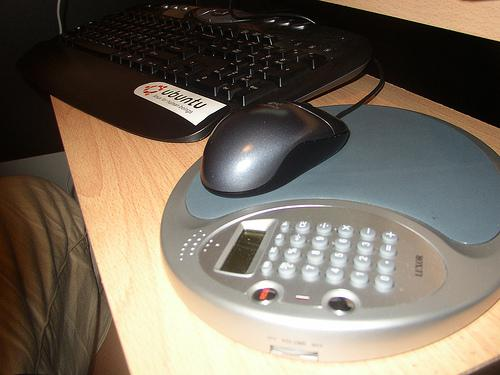Question: who is the mouse integrated with?
Choices:
A. A keypad.
B. A computer.
C. A cell phone.
D. An iPad.
Answer with the letter. Answer: A Question: how does a person use this keyboard?
Choices:
A. With their hands.
B. With their feet.
C. By speaking.
D. With their elbows.
Answer with the letter. Answer: A 